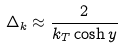<formula> <loc_0><loc_0><loc_500><loc_500>\Delta _ { k } \approx \frac { 2 } { k _ { T } \cosh y }</formula> 